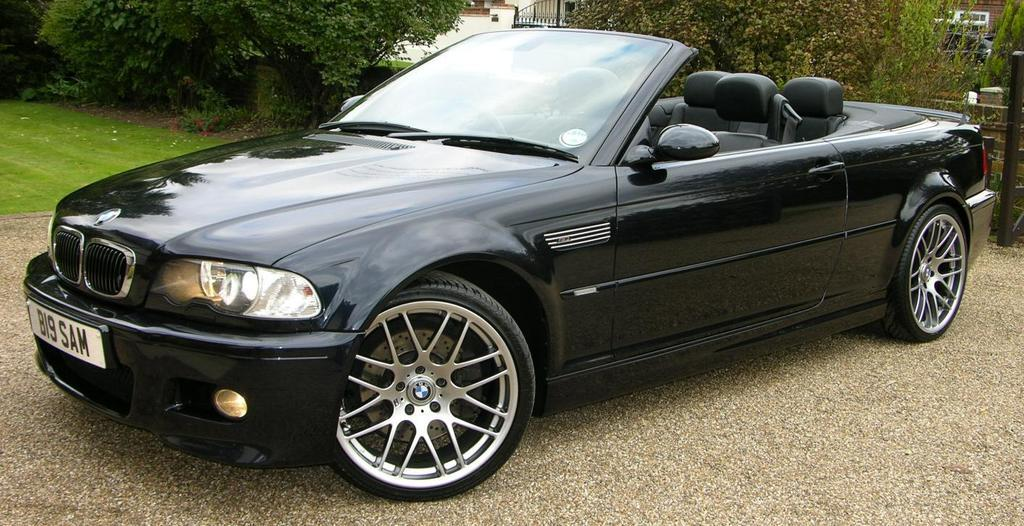What color is the car in the image? The car in the image is black. Where is the car located in the image? The car is parked on the road. What can be seen in the background of the image? There are many trees visible in the background of the image. What type of stick is the car using to change its interest in the image? There is no stick or change of interest present in the image; it simply shows a parked black car with trees in the background. 